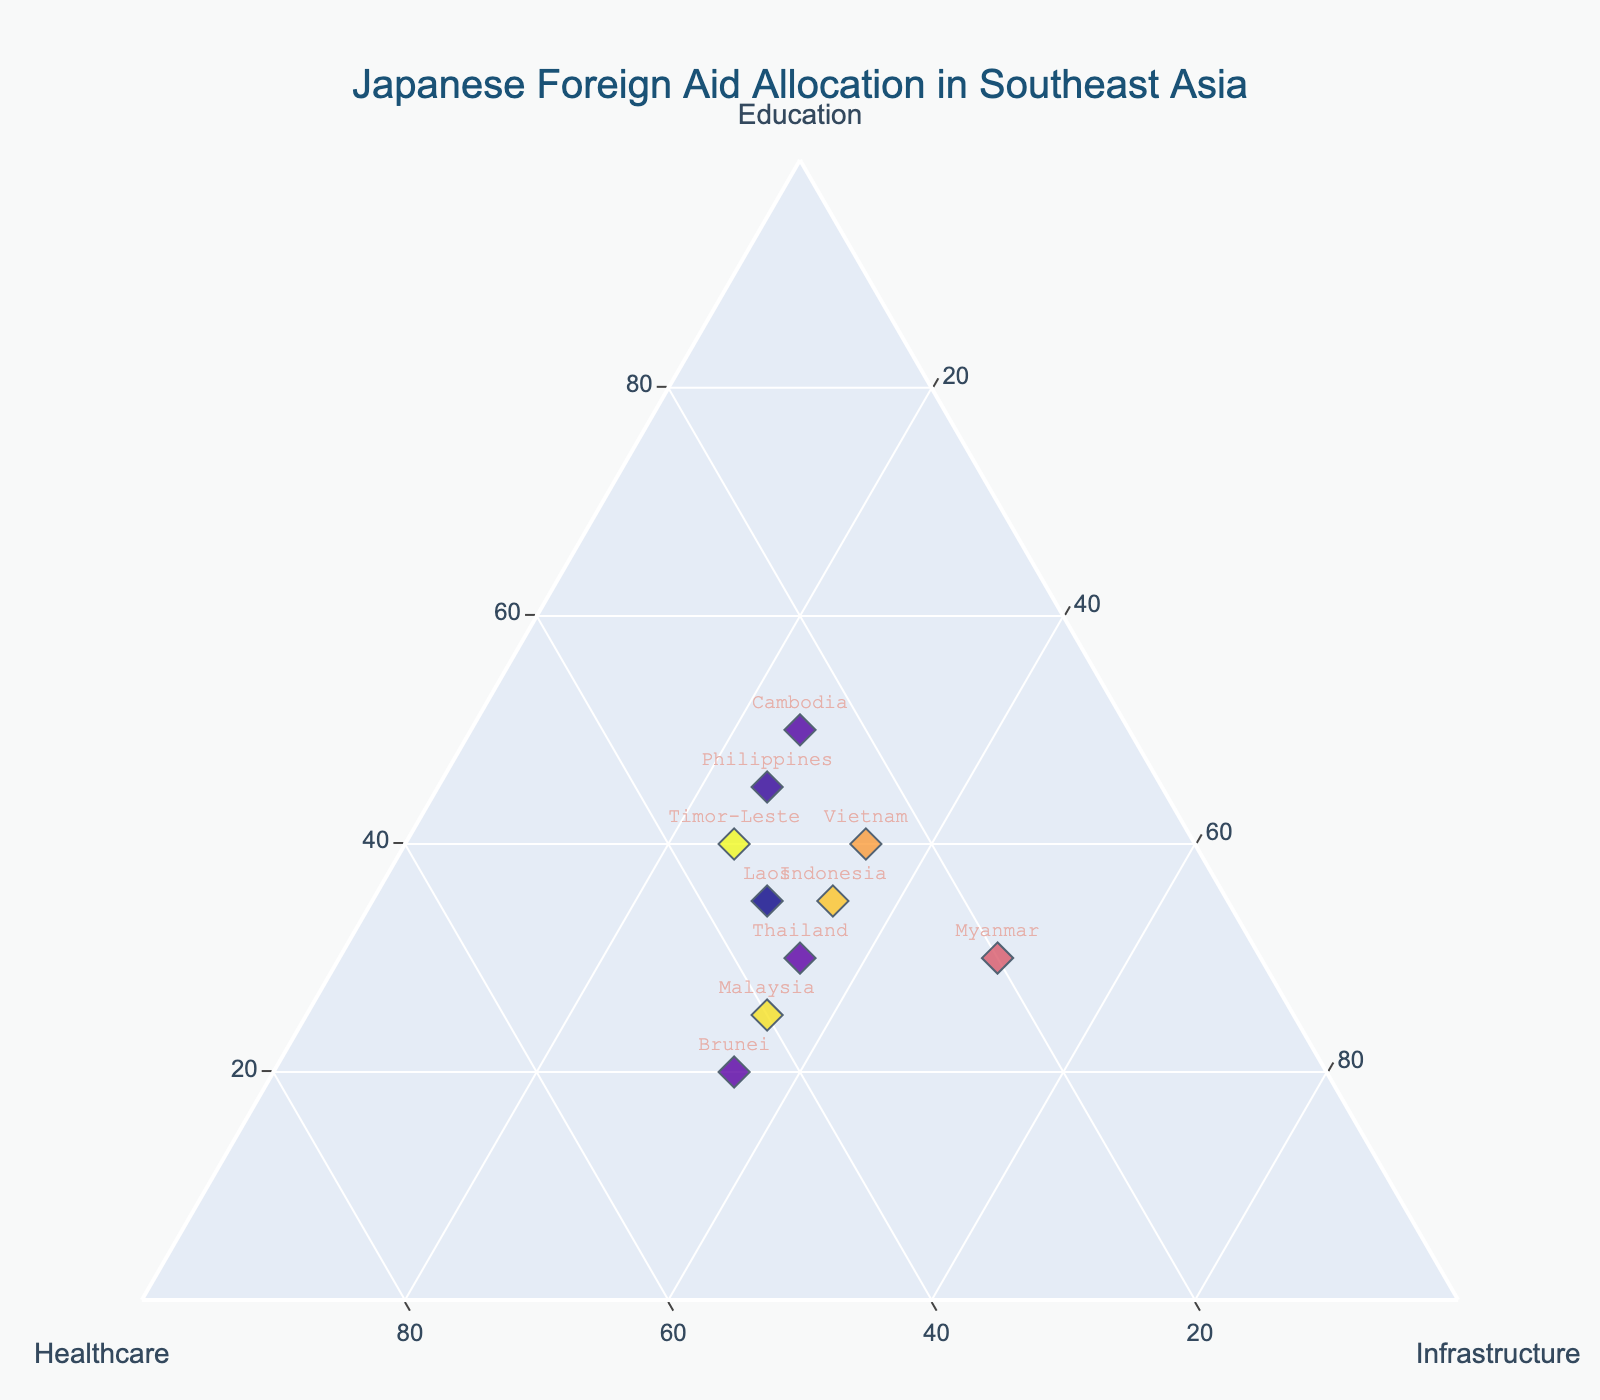Which country receives the most foreign aid for education? By looking at the data points on the ternary plot and checking the values for education, Cambodia receives 50% which is the highest allocation for education.
Answer: Cambodia Which country allocates the most aid toward healthcare? By examining the healthcare axis in the ternary plot and the given data, Brunei allocates 45% of aid toward healthcare which is the highest.
Answer: Brunei How is the aid divided for Vietnam? The aid for Vietnam is divided based on its position in the ternary plot: 40% for Education, 25% for Healthcare, and 35% for Infrastructure.
Answer: 40% Education, 25% Healthcare, 35% Infrastructure Which countries have equal aid allocation for infrastructure? By referring to the ternary plot and comparing the infrastructure values from the data, Indonesia, Vietnam, Thailand, and Malaysia have equal allocations of 35% to infrastructure.
Answer: Indonesia, Vietnam, Thailand, Malaysia Is there any country where education receives the same level of aid as infrastructure? From the ternary plot and given data, Indonesia allocates 35% to both education and infrastructure.
Answer: Indonesia What is the average percentage allocation for healthcare among all countries? Sum the healthcare percentages (30+25+35+30+40+25+20+35+35+45) to get 320. Divide this by the number of countries (10).
Answer: 32% Which country has the lowest allocation for education? Referring to the education axis in the ternary plot and the data, Brunei allocates only 20% to education which is the lowest.
Answer: Brunei Compare the allocation of aid between Cambodia and Myanmar. Cambodia allocates 50% to education, 25% to healthcare, and 25% to infrastructure, whereas Myanmar allocates 30% to education, 20% to healthcare, and 50% to infrastructure.
Answer: Cambodia: 50% Education, 25% Healthcare, 25% Infrastructure; Myanmar: 30% Education, 20% Healthcare, 50% Infrastructure What is the total percentage allocated to education by the top three countries? The top three allocations to education are Cambodia (50%), Philippines (45%), and Vietnam (40%). Summing these gives 50 + 45 + 40 = 135.
Answer: 135% Which country strikes the most balance in allocation among the three sectors? By observing countries with nearly equal aid percentages in each sector, Thailand has 30% for education, 35% for healthcare, and 35% for infrastructure.
Answer: Thailand 